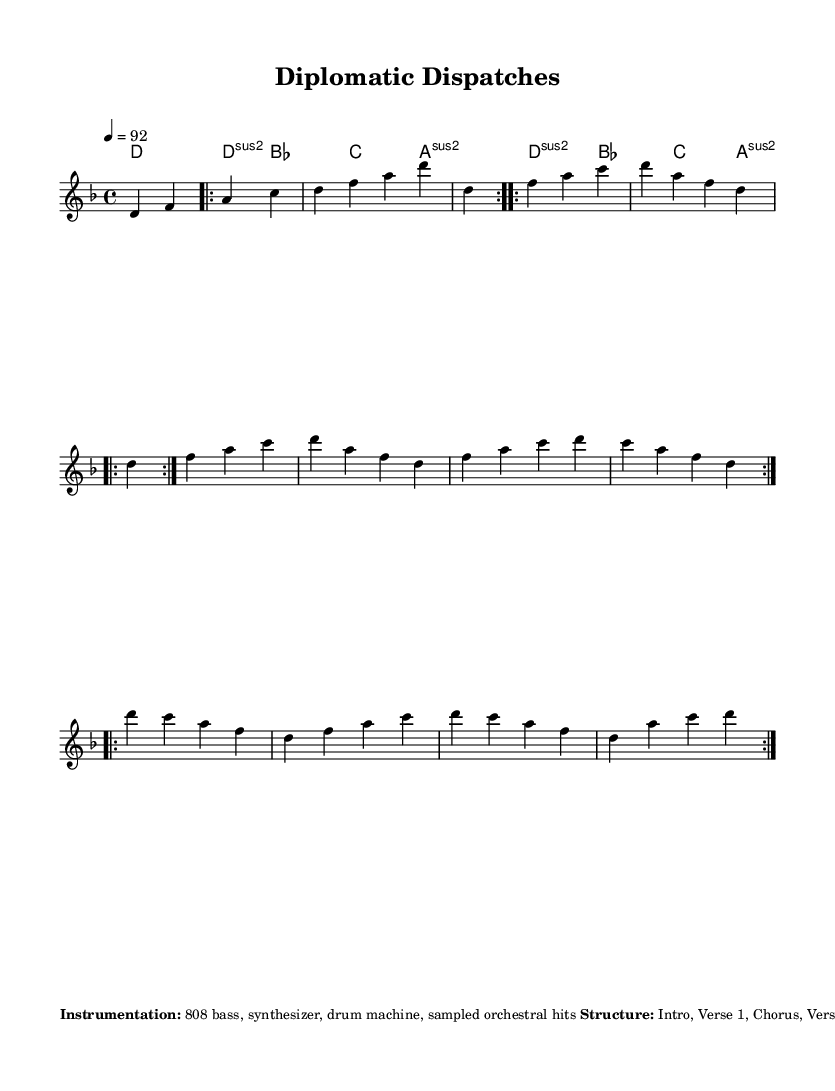What is the key signature of this music? The key signature indicates D minor, which has one flat (B-flat). This can be deduced from the global settings in the score.
Answer: D minor What is the time signature of this piece? The time signature is 4/4, suggesting that there are four beats in each measure. This is explicitly stated in the global settings.
Answer: 4/4 What tempo marking is provided for this music? The tempo marking indicates a tempo of 92 beats per minute, which is specified in the global settings as "4 = 92".
Answer: 92 How many verses are in this piece? There are two verses, as indicated by "repeat volta 2" in the section for the verse. The phrasing suggests repetition of the same lines.
Answer: 2 What type of instrumentation is specified for this music? The instrumentation includes an 808 bass, synthesizer, drum machine, and sampled orchestral hits, as listed in the additional notes section.
Answer: 808 bass, synthesizer, drum machine, sampled orchestral hits What historical event is referenced in the lyrical themes? The Treaty of Versailles is one of the historical events highlighted in the lyrical themes section of the score, indicating a focus on its significance.
Answer: Treaty of Versailles How is the synthesizer indicated to be played? The synthesizer should use staccato notes, which is specified in the additional notes section, indicating a specific playing style.
Answer: Staccato 